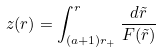<formula> <loc_0><loc_0><loc_500><loc_500>z ( r ) = \int ^ { r } _ { ( a + 1 ) r _ { + } } \frac { d \tilde { r } } { F ( \tilde { r } ) }</formula> 